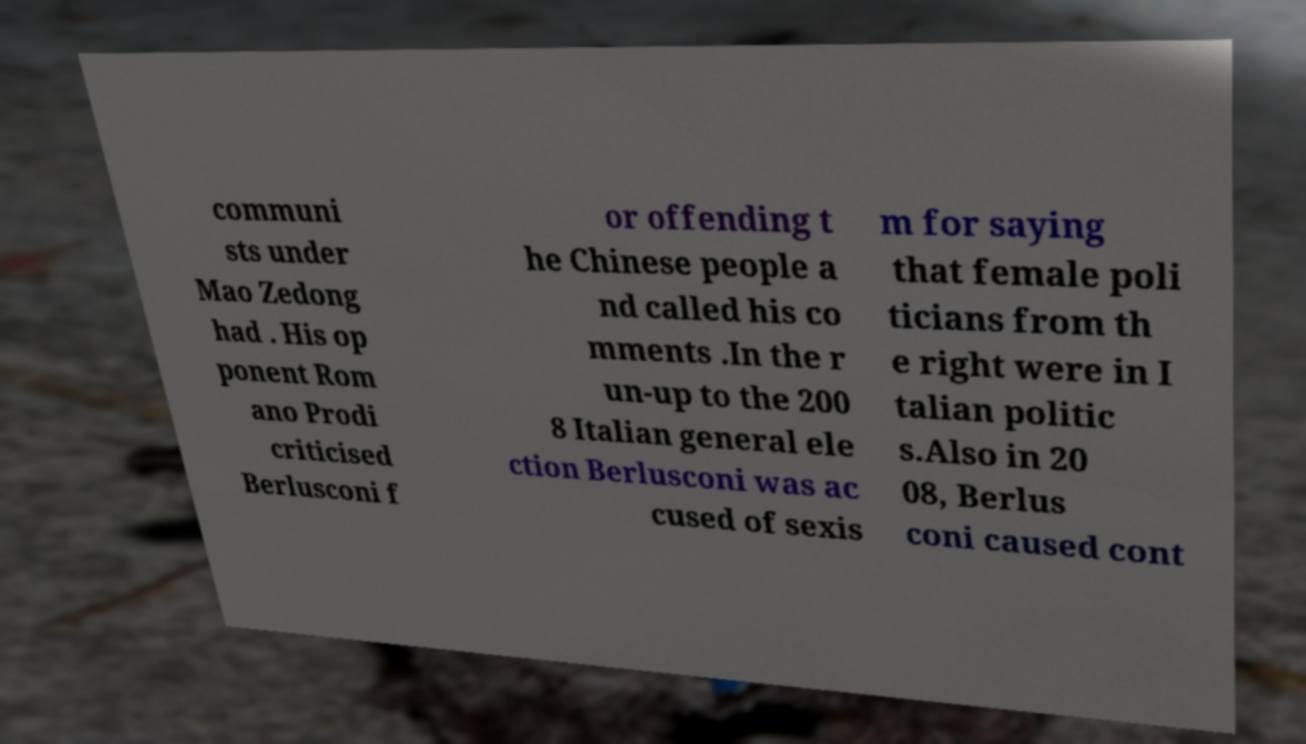For documentation purposes, I need the text within this image transcribed. Could you provide that? communi sts under Mao Zedong had . His op ponent Rom ano Prodi criticised Berlusconi f or offending t he Chinese people a nd called his co mments .In the r un-up to the 200 8 Italian general ele ction Berlusconi was ac cused of sexis m for saying that female poli ticians from th e right were in I talian politic s.Also in 20 08, Berlus coni caused cont 